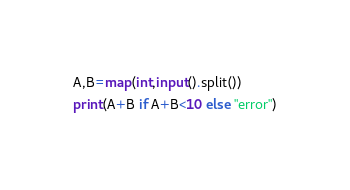Convert code to text. <code><loc_0><loc_0><loc_500><loc_500><_Python_>A,B=map(int,input().split())
print(A+B if A+B<10 else "error")</code> 